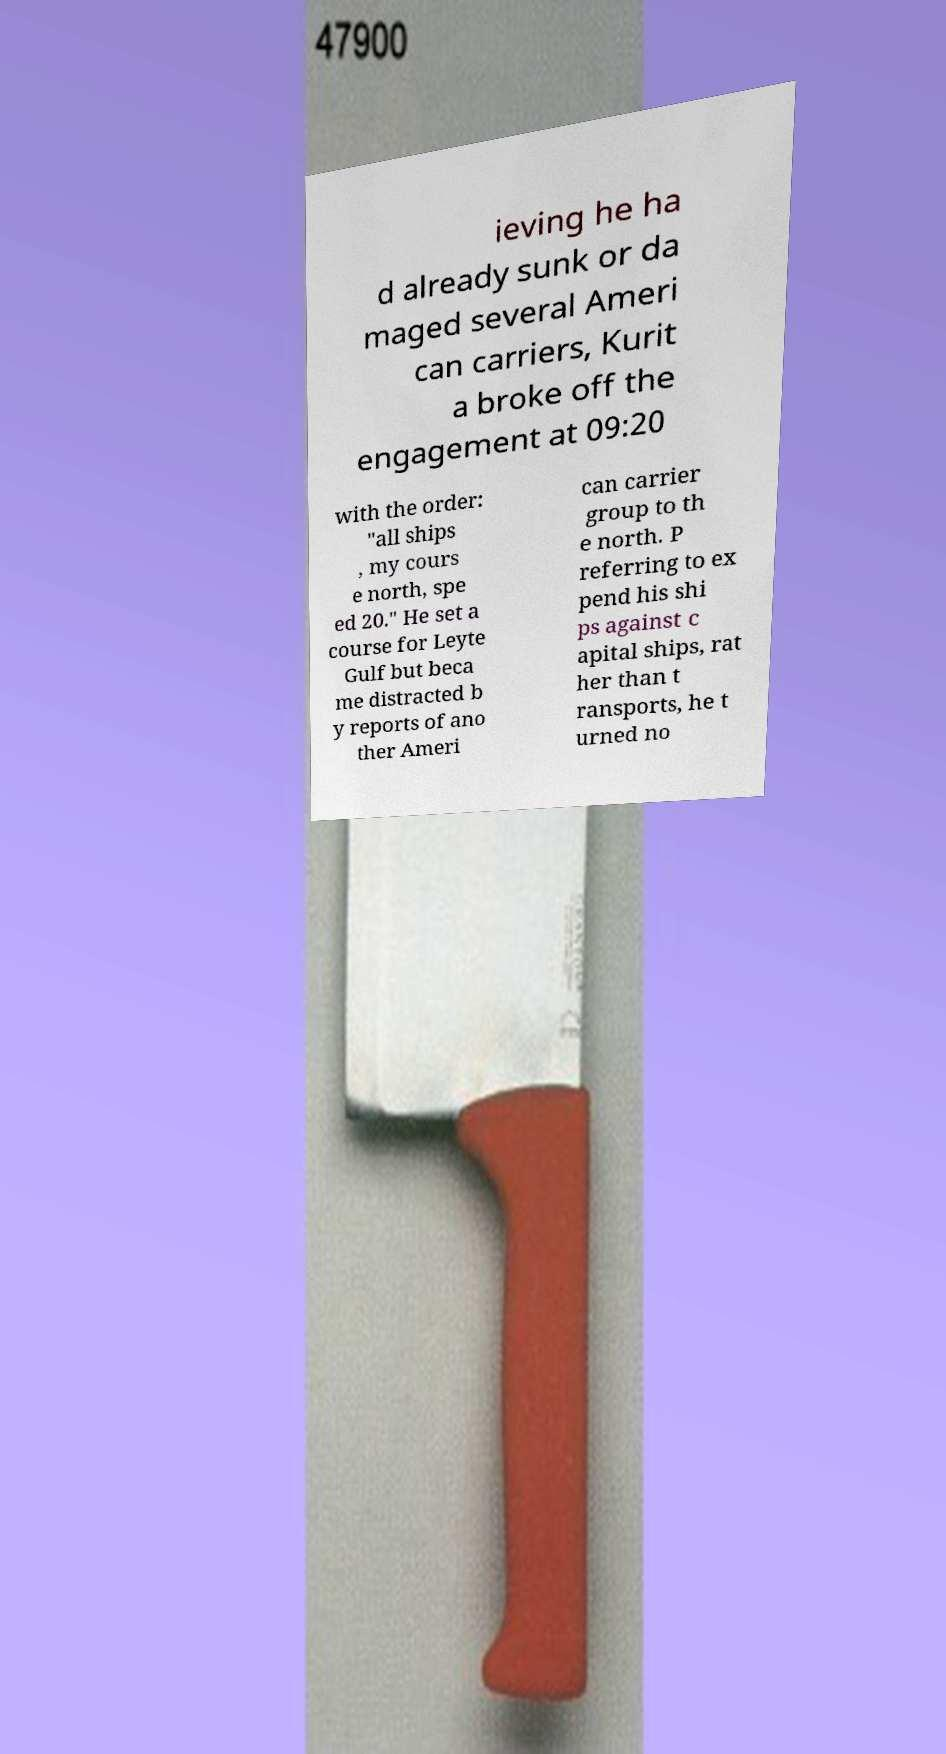Please read and relay the text visible in this image. What does it say? ieving he ha d already sunk or da maged several Ameri can carriers, Kurit a broke off the engagement at 09:20 with the order: "all ships , my cours e north, spe ed 20." He set a course for Leyte Gulf but beca me distracted b y reports of ano ther Ameri can carrier group to th e north. P referring to ex pend his shi ps against c apital ships, rat her than t ransports, he t urned no 